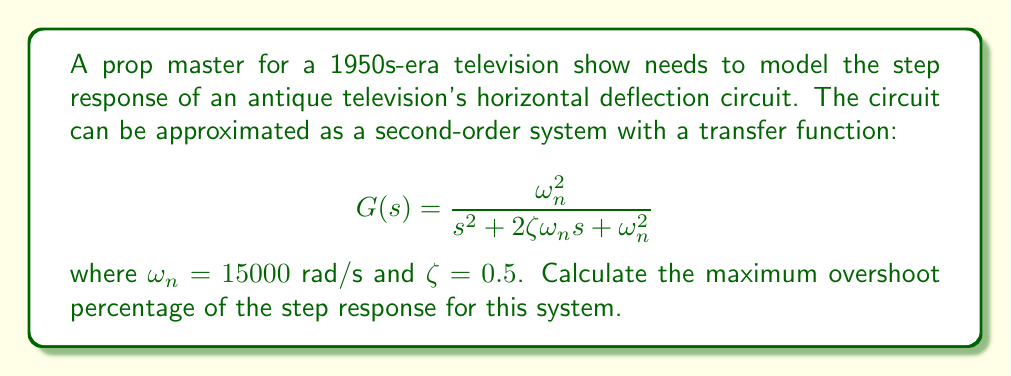Help me with this question. To solve this problem, we'll follow these steps:

1) The maximum overshoot percentage (MP) for a second-order system is given by the formula:

   $$MP = e^{-\zeta\pi/\sqrt{1-\zeta^2}} \times 100\%$$

2) We're given that $\zeta = 0.5$. Let's substitute this into the formula:

   $$MP = e^{-0.5\pi/\sqrt{1-0.5^2}} \times 100\%$$

3) Simplify the expression under the square root:
   
   $$MP = e^{-0.5\pi/\sqrt{0.75}} \times 100\%$$

4) Calculate the value under the square root:
   
   $$MP = e^{-0.5\pi/0.866} \times 100\%$$

5) Evaluate the exponent:
   
   $$MP = e^{-1.8138} \times 100\%$$

6) Calculate the final result:
   
   $$MP = 0.1631 \times 100\% = 16.31\%$$

The maximum overshoot percentage is approximately 16.31%.
Answer: 16.31% 